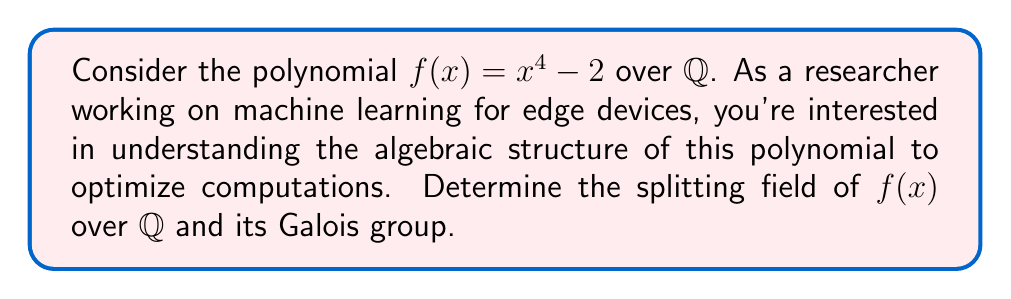Solve this math problem. Step 1: Find the roots of $f(x)$
The roots of $x^4 - 2 = 0$ are:
$x = \pm \sqrt[4]{2}$ and $\pm i\sqrt[4]{2}$

Step 2: Determine the splitting field
The splitting field $K$ is the smallest field extension of $\mathbb{Q}$ containing all roots of $f(x)$. Here, $K = \mathbb{Q}(\sqrt[4]{2}, i)$.

Step 3: Express $K$ as a tower of extensions
$\mathbb{Q} \subset \mathbb{Q}(\sqrt[4]{2}) \subset \mathbb{Q}(\sqrt[4]{2}, i)$

Step 4: Calculate the degree of each extension
$[\mathbb{Q}(\sqrt[4]{2}) : \mathbb{Q}] = 4$
$[\mathbb{Q}(\sqrt[4]{2}, i) : \mathbb{Q}(\sqrt[4]{2})] = 2$

Step 5: Determine the degree of $K$ over $\mathbb{Q}$
$[K : \mathbb{Q}] = 4 \cdot 2 = 8$

Step 6: Identify the Galois group
The Galois group $G = Gal(K/\mathbb{Q})$ consists of automorphisms of $K$ that fix $\mathbb{Q}$. These automorphisms permute the roots of $f(x)$.

Let $\zeta = \sqrt[4]{2}$. The automorphisms are:
1. Identity: $\sigma_1(\zeta) = \zeta, \sigma_1(i) = i$
2. $\sigma_2(\zeta) = i\zeta, \sigma_2(i) = i$
3. $\sigma_3(\zeta) = -\zeta, \sigma_3(i) = i$
4. $\sigma_4(\zeta) = -i\zeta, \sigma_4(i) = i$
5. $\sigma_5(\zeta) = \zeta, \sigma_5(i) = -i$
6. $\sigma_6(\zeta) = i\zeta, \sigma_6(i) = -i$
7. $\sigma_7(\zeta) = -\zeta, \sigma_7(i) = -i$
8. $\sigma_8(\zeta) = -i\zeta, \sigma_8(i) = -i$

The Galois group $G$ is isomorphic to the dihedral group $D_4$ of order 8.
Answer: $K = \mathbb{Q}(\sqrt[4]{2}, i)$, $[K : \mathbb{Q}] = 8$, $Gal(K/\mathbb{Q}) \cong D_4$ 